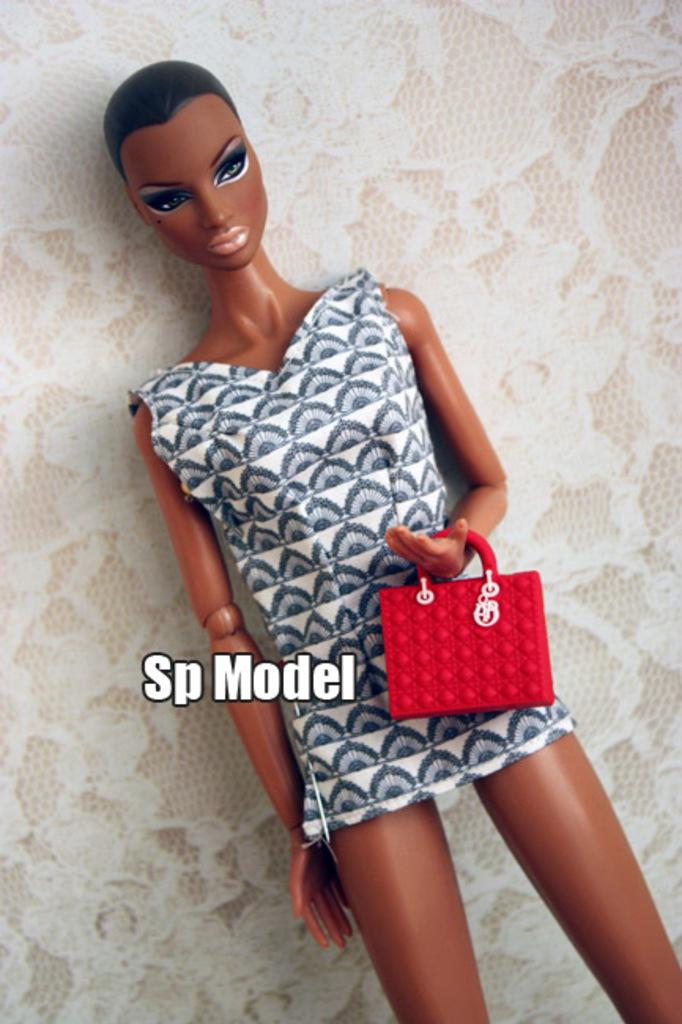What is the main subject of the image? There is a doll in the image. What is the doll wearing? The doll is wearing a white and black dress. What is the doll holding? The doll is holding a red bag. What can be seen in the background of the image? There is a wall in the background of the image. What is on the wall? There is a wallpaper on the wall. What is the doll's belief about the wilderness in the image? The image does not provide any information about the doll's beliefs or the wilderness, as it only shows the doll and its surroundings. 